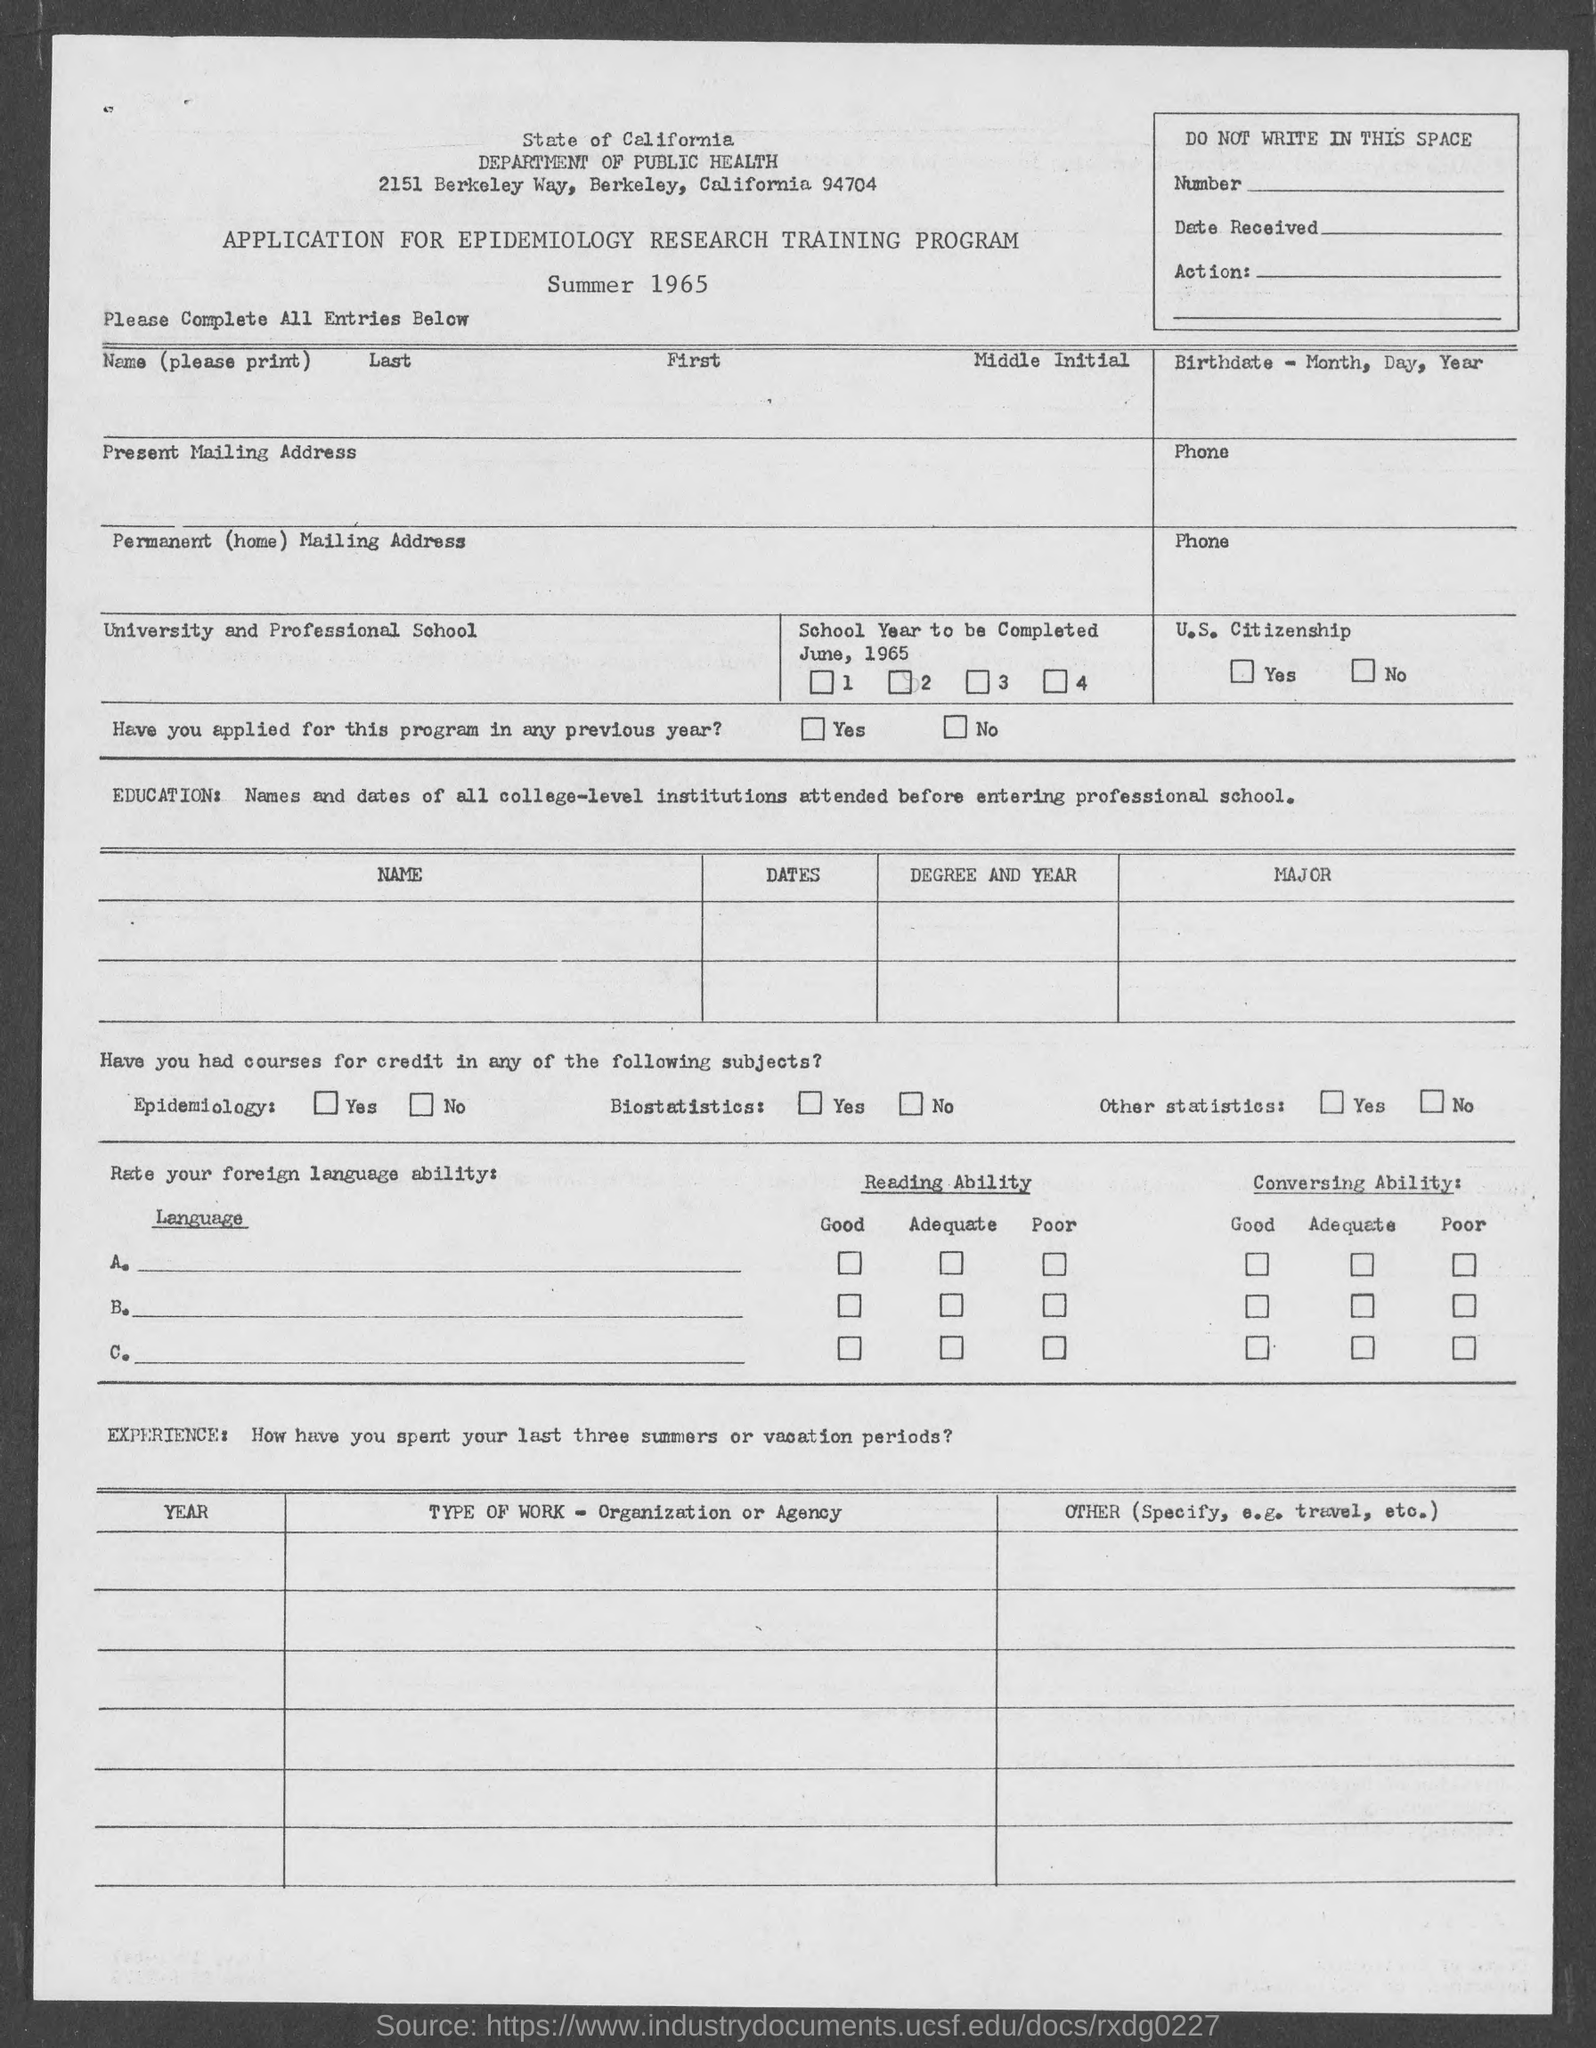In which city is state of california department of public health located  ?
Your answer should be compact. 2151 Berkeley way. 